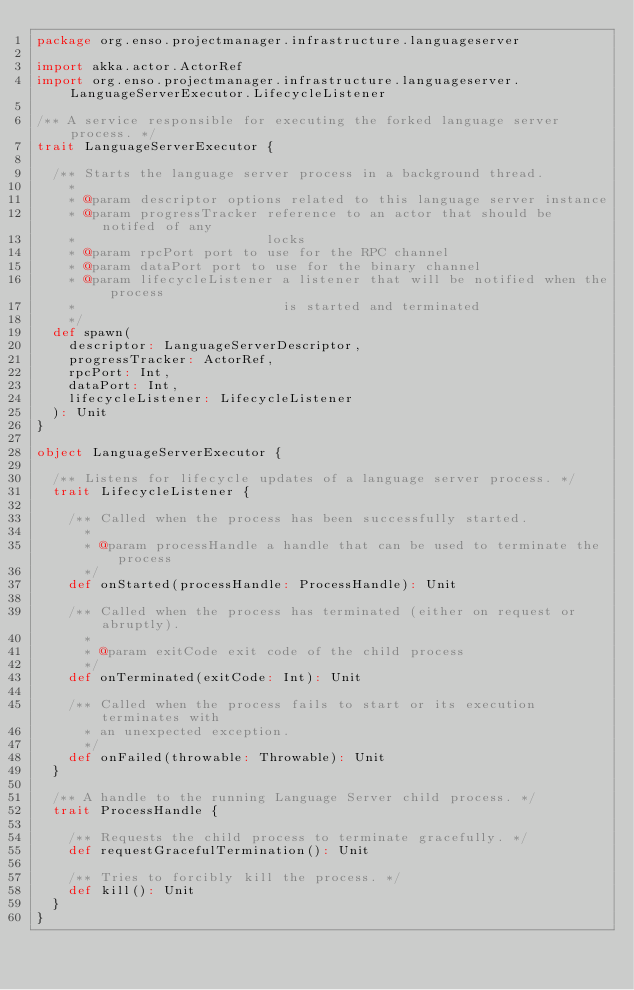<code> <loc_0><loc_0><loc_500><loc_500><_Scala_>package org.enso.projectmanager.infrastructure.languageserver

import akka.actor.ActorRef
import org.enso.projectmanager.infrastructure.languageserver.LanguageServerExecutor.LifecycleListener

/** A service responsible for executing the forked language server process. */
trait LanguageServerExecutor {

  /** Starts the language server process in a background thread.
    *
    * @param descriptor options related to this language server instance
    * @param progressTracker reference to an actor that should be notifed of any
    *                        locks
    * @param rpcPort port to use for the RPC channel
    * @param dataPort port to use for the binary channel
    * @param lifecycleListener a listener that will be notified when the process
    *                          is started and terminated
    */
  def spawn(
    descriptor: LanguageServerDescriptor,
    progressTracker: ActorRef,
    rpcPort: Int,
    dataPort: Int,
    lifecycleListener: LifecycleListener
  ): Unit
}

object LanguageServerExecutor {

  /** Listens for lifecycle updates of a language server process. */
  trait LifecycleListener {

    /** Called when the process has been successfully started.
      *
      * @param processHandle a handle that can be used to terminate the process
      */
    def onStarted(processHandle: ProcessHandle): Unit

    /** Called when the process has terminated (either on request or abruptly).
      *
      * @param exitCode exit code of the child process
      */
    def onTerminated(exitCode: Int): Unit

    /** Called when the process fails to start or its execution terminates with
      * an unexpected exception.
      */
    def onFailed(throwable: Throwable): Unit
  }

  /** A handle to the running Language Server child process. */
  trait ProcessHandle {

    /** Requests the child process to terminate gracefully. */
    def requestGracefulTermination(): Unit

    /** Tries to forcibly kill the process. */
    def kill(): Unit
  }
}
</code> 